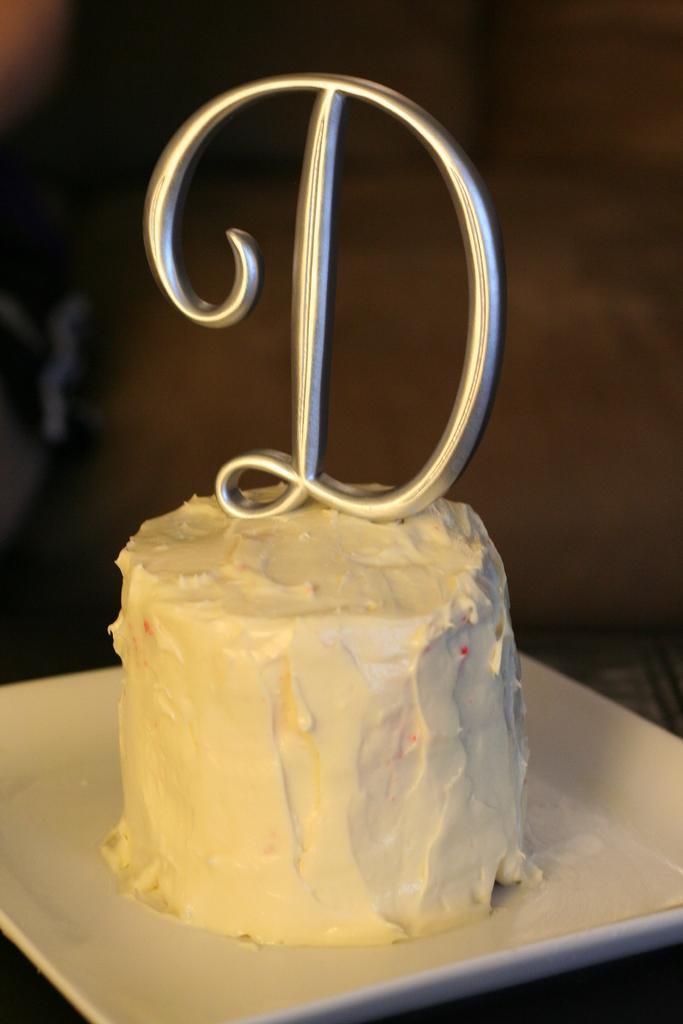What is the main subject of the image? There is a cake in the image. How is the cake presented? The cake is on a plate. What is written or depicted on the cake? There is an alphabet on the cake. Can you describe the background of the image? The background of the image is blurred. How many geese are visible in the image? There are no geese present in the image. What type of rail can be seen supporting the cake? There is no rail present in the image; the cake is on a plate. 